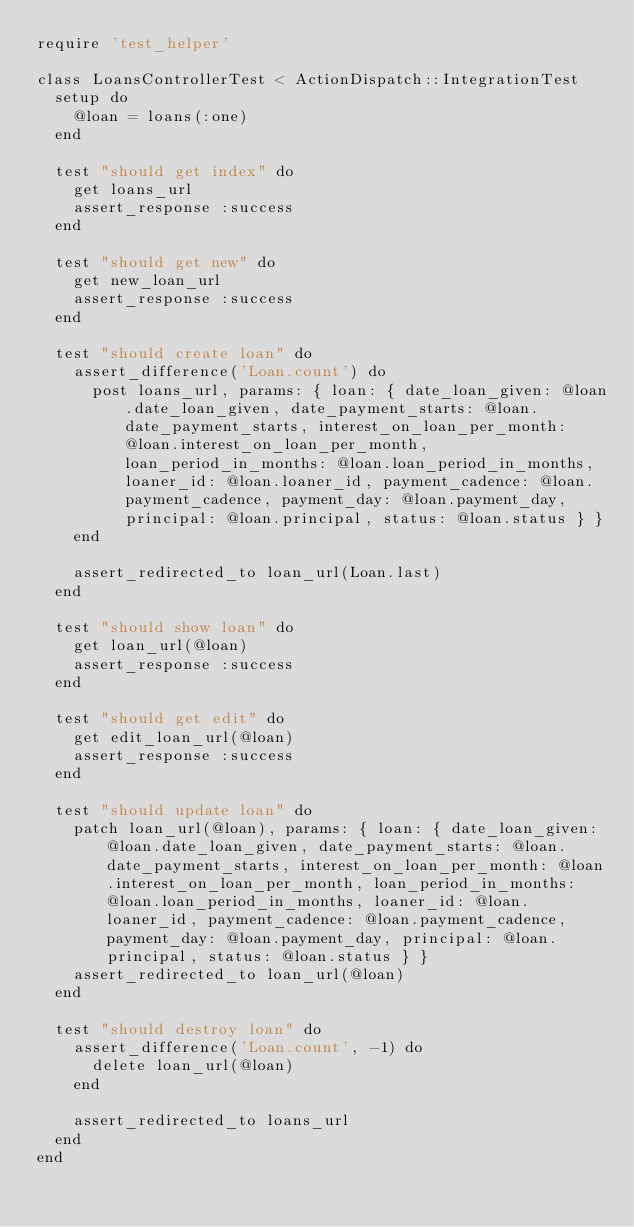Convert code to text. <code><loc_0><loc_0><loc_500><loc_500><_Ruby_>require 'test_helper'

class LoansControllerTest < ActionDispatch::IntegrationTest
  setup do
    @loan = loans(:one)
  end

  test "should get index" do
    get loans_url
    assert_response :success
  end

  test "should get new" do
    get new_loan_url
    assert_response :success
  end

  test "should create loan" do
    assert_difference('Loan.count') do
      post loans_url, params: { loan: { date_loan_given: @loan.date_loan_given, date_payment_starts: @loan.date_payment_starts, interest_on_loan_per_month: @loan.interest_on_loan_per_month, loan_period_in_months: @loan.loan_period_in_months, loaner_id: @loan.loaner_id, payment_cadence: @loan.payment_cadence, payment_day: @loan.payment_day, principal: @loan.principal, status: @loan.status } }
    end

    assert_redirected_to loan_url(Loan.last)
  end

  test "should show loan" do
    get loan_url(@loan)
    assert_response :success
  end

  test "should get edit" do
    get edit_loan_url(@loan)
    assert_response :success
  end

  test "should update loan" do
    patch loan_url(@loan), params: { loan: { date_loan_given: @loan.date_loan_given, date_payment_starts: @loan.date_payment_starts, interest_on_loan_per_month: @loan.interest_on_loan_per_month, loan_period_in_months: @loan.loan_period_in_months, loaner_id: @loan.loaner_id, payment_cadence: @loan.payment_cadence, payment_day: @loan.payment_day, principal: @loan.principal, status: @loan.status } }
    assert_redirected_to loan_url(@loan)
  end

  test "should destroy loan" do
    assert_difference('Loan.count', -1) do
      delete loan_url(@loan)
    end

    assert_redirected_to loans_url
  end
end
</code> 